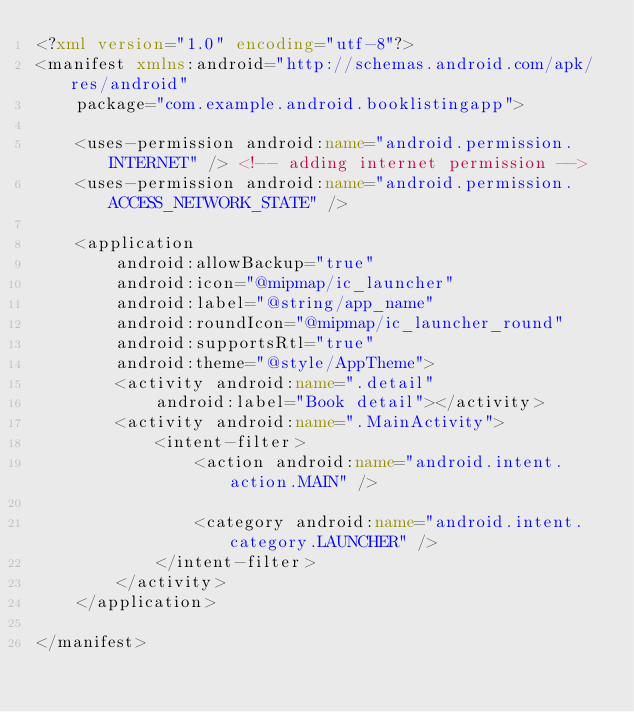<code> <loc_0><loc_0><loc_500><loc_500><_XML_><?xml version="1.0" encoding="utf-8"?>
<manifest xmlns:android="http://schemas.android.com/apk/res/android"
    package="com.example.android.booklistingapp">

    <uses-permission android:name="android.permission.INTERNET" /> <!-- adding internet permission -->
    <uses-permission android:name="android.permission.ACCESS_NETWORK_STATE" />

    <application
        android:allowBackup="true"
        android:icon="@mipmap/ic_launcher"
        android:label="@string/app_name"
        android:roundIcon="@mipmap/ic_launcher_round"
        android:supportsRtl="true"
        android:theme="@style/AppTheme">
        <activity android:name=".detail"
            android:label="Book detail"></activity>
        <activity android:name=".MainActivity">
            <intent-filter>
                <action android:name="android.intent.action.MAIN" />

                <category android:name="android.intent.category.LAUNCHER" />
            </intent-filter>
        </activity>
    </application>

</manifest></code> 